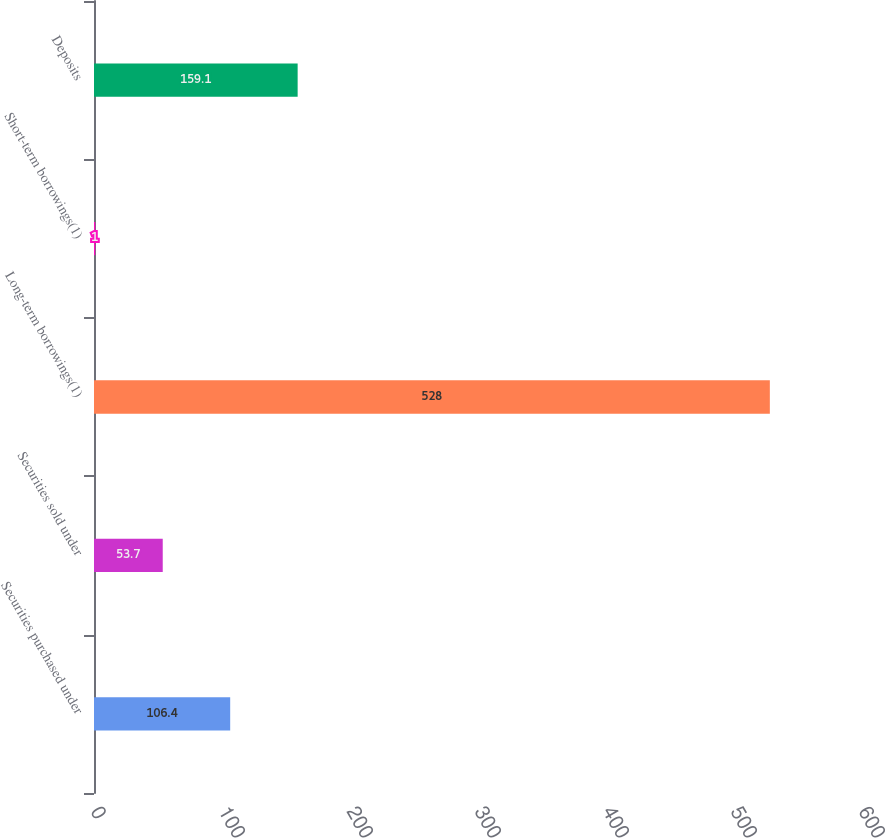Convert chart. <chart><loc_0><loc_0><loc_500><loc_500><bar_chart><fcel>Securities purchased under<fcel>Securities sold under<fcel>Long-term borrowings(1)<fcel>Short-term borrowings(1)<fcel>Deposits<nl><fcel>106.4<fcel>53.7<fcel>528<fcel>1<fcel>159.1<nl></chart> 